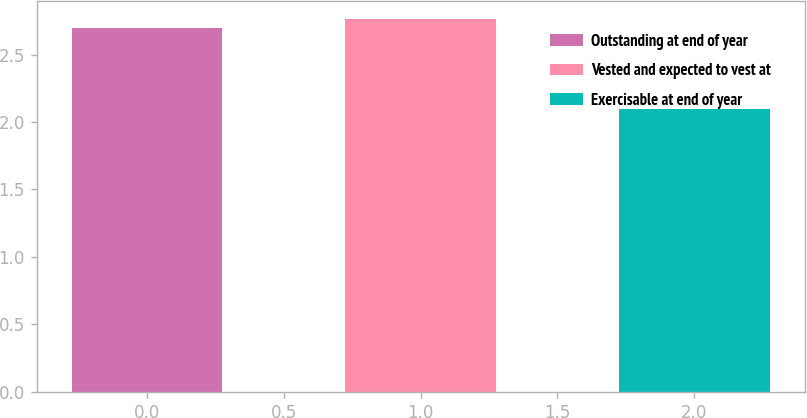<chart> <loc_0><loc_0><loc_500><loc_500><bar_chart><fcel>Outstanding at end of year<fcel>Vested and expected to vest at<fcel>Exercisable at end of year<nl><fcel>2.7<fcel>2.76<fcel>2.1<nl></chart> 